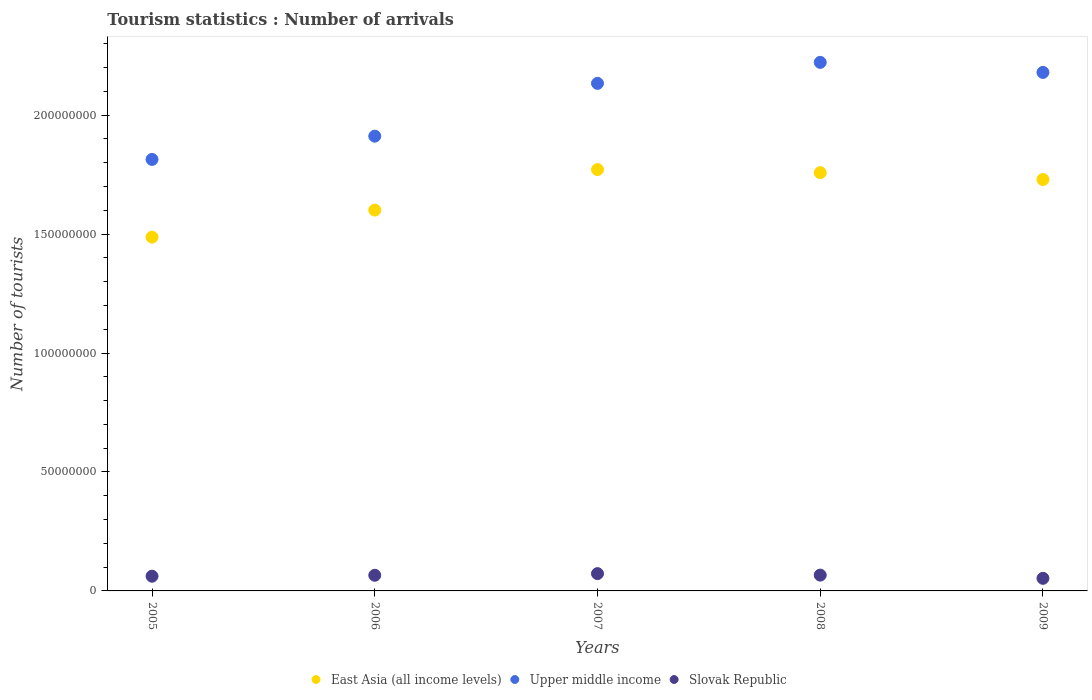How many different coloured dotlines are there?
Provide a short and direct response. 3. Is the number of dotlines equal to the number of legend labels?
Keep it short and to the point. Yes. What is the number of tourist arrivals in Slovak Republic in 2008?
Provide a short and direct response. 6.64e+06. Across all years, what is the maximum number of tourist arrivals in Slovak Republic?
Offer a very short reply. 7.27e+06. Across all years, what is the minimum number of tourist arrivals in Upper middle income?
Your answer should be compact. 1.81e+08. In which year was the number of tourist arrivals in East Asia (all income levels) maximum?
Provide a succinct answer. 2007. In which year was the number of tourist arrivals in East Asia (all income levels) minimum?
Offer a terse response. 2005. What is the total number of tourist arrivals in Slovak Republic in the graph?
Your answer should be very brief. 3.20e+07. What is the difference between the number of tourist arrivals in Slovak Republic in 2008 and that in 2009?
Keep it short and to the point. 1.34e+06. What is the difference between the number of tourist arrivals in Slovak Republic in 2006 and the number of tourist arrivals in Upper middle income in 2009?
Offer a terse response. -2.11e+08. What is the average number of tourist arrivals in East Asia (all income levels) per year?
Your answer should be compact. 1.67e+08. In the year 2007, what is the difference between the number of tourist arrivals in Upper middle income and number of tourist arrivals in East Asia (all income levels)?
Keep it short and to the point. 3.62e+07. In how many years, is the number of tourist arrivals in Upper middle income greater than 210000000?
Ensure brevity in your answer.  3. What is the ratio of the number of tourist arrivals in Upper middle income in 2005 to that in 2006?
Your answer should be very brief. 0.95. What is the difference between the highest and the second highest number of tourist arrivals in Upper middle income?
Give a very brief answer. 4.22e+06. What is the difference between the highest and the lowest number of tourist arrivals in East Asia (all income levels)?
Give a very brief answer. 2.84e+07. In how many years, is the number of tourist arrivals in East Asia (all income levels) greater than the average number of tourist arrivals in East Asia (all income levels) taken over all years?
Your response must be concise. 3. Is the sum of the number of tourist arrivals in East Asia (all income levels) in 2006 and 2008 greater than the maximum number of tourist arrivals in Upper middle income across all years?
Your answer should be compact. Yes. How many dotlines are there?
Provide a short and direct response. 3. What is the difference between two consecutive major ticks on the Y-axis?
Provide a short and direct response. 5.00e+07. Does the graph contain any zero values?
Make the answer very short. No. What is the title of the graph?
Make the answer very short. Tourism statistics : Number of arrivals. What is the label or title of the X-axis?
Provide a succinct answer. Years. What is the label or title of the Y-axis?
Provide a succinct answer. Number of tourists. What is the Number of tourists in East Asia (all income levels) in 2005?
Provide a succinct answer. 1.49e+08. What is the Number of tourists in Upper middle income in 2005?
Offer a terse response. 1.81e+08. What is the Number of tourists in Slovak Republic in 2005?
Make the answer very short. 6.18e+06. What is the Number of tourists of East Asia (all income levels) in 2006?
Provide a succinct answer. 1.60e+08. What is the Number of tourists of Upper middle income in 2006?
Make the answer very short. 1.91e+08. What is the Number of tourists in Slovak Republic in 2006?
Give a very brief answer. 6.58e+06. What is the Number of tourists of East Asia (all income levels) in 2007?
Your answer should be compact. 1.77e+08. What is the Number of tourists of Upper middle income in 2007?
Give a very brief answer. 2.13e+08. What is the Number of tourists of Slovak Republic in 2007?
Your response must be concise. 7.27e+06. What is the Number of tourists of East Asia (all income levels) in 2008?
Give a very brief answer. 1.76e+08. What is the Number of tourists of Upper middle income in 2008?
Keep it short and to the point. 2.22e+08. What is the Number of tourists of Slovak Republic in 2008?
Your answer should be very brief. 6.64e+06. What is the Number of tourists of East Asia (all income levels) in 2009?
Ensure brevity in your answer.  1.73e+08. What is the Number of tourists of Upper middle income in 2009?
Offer a terse response. 2.18e+08. What is the Number of tourists of Slovak Republic in 2009?
Offer a terse response. 5.30e+06. Across all years, what is the maximum Number of tourists of East Asia (all income levels)?
Your answer should be very brief. 1.77e+08. Across all years, what is the maximum Number of tourists of Upper middle income?
Provide a short and direct response. 2.22e+08. Across all years, what is the maximum Number of tourists of Slovak Republic?
Make the answer very short. 7.27e+06. Across all years, what is the minimum Number of tourists of East Asia (all income levels)?
Give a very brief answer. 1.49e+08. Across all years, what is the minimum Number of tourists in Upper middle income?
Your answer should be compact. 1.81e+08. Across all years, what is the minimum Number of tourists of Slovak Republic?
Keep it short and to the point. 5.30e+06. What is the total Number of tourists in East Asia (all income levels) in the graph?
Offer a terse response. 8.35e+08. What is the total Number of tourists of Upper middle income in the graph?
Provide a succinct answer. 1.03e+09. What is the total Number of tourists of Slovak Republic in the graph?
Keep it short and to the point. 3.20e+07. What is the difference between the Number of tourists of East Asia (all income levels) in 2005 and that in 2006?
Provide a short and direct response. -1.14e+07. What is the difference between the Number of tourists in Upper middle income in 2005 and that in 2006?
Give a very brief answer. -9.77e+06. What is the difference between the Number of tourists in Slovak Republic in 2005 and that in 2006?
Offer a terse response. -3.95e+05. What is the difference between the Number of tourists of East Asia (all income levels) in 2005 and that in 2007?
Keep it short and to the point. -2.84e+07. What is the difference between the Number of tourists of Upper middle income in 2005 and that in 2007?
Your answer should be compact. -3.20e+07. What is the difference between the Number of tourists of Slovak Republic in 2005 and that in 2007?
Your response must be concise. -1.08e+06. What is the difference between the Number of tourists in East Asia (all income levels) in 2005 and that in 2008?
Provide a succinct answer. -2.71e+07. What is the difference between the Number of tourists of Upper middle income in 2005 and that in 2008?
Provide a succinct answer. -4.08e+07. What is the difference between the Number of tourists of Slovak Republic in 2005 and that in 2008?
Offer a very short reply. -4.59e+05. What is the difference between the Number of tourists in East Asia (all income levels) in 2005 and that in 2009?
Provide a succinct answer. -2.42e+07. What is the difference between the Number of tourists of Upper middle income in 2005 and that in 2009?
Ensure brevity in your answer.  -3.66e+07. What is the difference between the Number of tourists in Slovak Republic in 2005 and that in 2009?
Provide a short and direct response. 8.86e+05. What is the difference between the Number of tourists of East Asia (all income levels) in 2006 and that in 2007?
Offer a very short reply. -1.70e+07. What is the difference between the Number of tourists in Upper middle income in 2006 and that in 2007?
Your answer should be compact. -2.22e+07. What is the difference between the Number of tourists in Slovak Republic in 2006 and that in 2007?
Offer a very short reply. -6.90e+05. What is the difference between the Number of tourists of East Asia (all income levels) in 2006 and that in 2008?
Keep it short and to the point. -1.57e+07. What is the difference between the Number of tourists in Upper middle income in 2006 and that in 2008?
Offer a very short reply. -3.10e+07. What is the difference between the Number of tourists of Slovak Republic in 2006 and that in 2008?
Provide a succinct answer. -6.40e+04. What is the difference between the Number of tourists in East Asia (all income levels) in 2006 and that in 2009?
Ensure brevity in your answer.  -1.29e+07. What is the difference between the Number of tourists of Upper middle income in 2006 and that in 2009?
Keep it short and to the point. -2.68e+07. What is the difference between the Number of tourists in Slovak Republic in 2006 and that in 2009?
Keep it short and to the point. 1.28e+06. What is the difference between the Number of tourists of East Asia (all income levels) in 2007 and that in 2008?
Give a very brief answer. 1.30e+06. What is the difference between the Number of tourists of Upper middle income in 2007 and that in 2008?
Provide a succinct answer. -8.82e+06. What is the difference between the Number of tourists in Slovak Republic in 2007 and that in 2008?
Provide a short and direct response. 6.26e+05. What is the difference between the Number of tourists of East Asia (all income levels) in 2007 and that in 2009?
Your answer should be compact. 4.18e+06. What is the difference between the Number of tourists in Upper middle income in 2007 and that in 2009?
Offer a very short reply. -4.60e+06. What is the difference between the Number of tourists in Slovak Republic in 2007 and that in 2009?
Keep it short and to the point. 1.97e+06. What is the difference between the Number of tourists of East Asia (all income levels) in 2008 and that in 2009?
Your answer should be very brief. 2.88e+06. What is the difference between the Number of tourists in Upper middle income in 2008 and that in 2009?
Your answer should be very brief. 4.22e+06. What is the difference between the Number of tourists of Slovak Republic in 2008 and that in 2009?
Offer a very short reply. 1.34e+06. What is the difference between the Number of tourists of East Asia (all income levels) in 2005 and the Number of tourists of Upper middle income in 2006?
Offer a terse response. -4.24e+07. What is the difference between the Number of tourists of East Asia (all income levels) in 2005 and the Number of tourists of Slovak Republic in 2006?
Provide a short and direct response. 1.42e+08. What is the difference between the Number of tourists in Upper middle income in 2005 and the Number of tourists in Slovak Republic in 2006?
Offer a terse response. 1.75e+08. What is the difference between the Number of tourists in East Asia (all income levels) in 2005 and the Number of tourists in Upper middle income in 2007?
Your response must be concise. -6.46e+07. What is the difference between the Number of tourists of East Asia (all income levels) in 2005 and the Number of tourists of Slovak Republic in 2007?
Keep it short and to the point. 1.41e+08. What is the difference between the Number of tourists in Upper middle income in 2005 and the Number of tourists in Slovak Republic in 2007?
Your answer should be compact. 1.74e+08. What is the difference between the Number of tourists of East Asia (all income levels) in 2005 and the Number of tourists of Upper middle income in 2008?
Your answer should be compact. -7.35e+07. What is the difference between the Number of tourists in East Asia (all income levels) in 2005 and the Number of tourists in Slovak Republic in 2008?
Your answer should be very brief. 1.42e+08. What is the difference between the Number of tourists in Upper middle income in 2005 and the Number of tourists in Slovak Republic in 2008?
Provide a succinct answer. 1.75e+08. What is the difference between the Number of tourists in East Asia (all income levels) in 2005 and the Number of tourists in Upper middle income in 2009?
Give a very brief answer. -6.92e+07. What is the difference between the Number of tourists of East Asia (all income levels) in 2005 and the Number of tourists of Slovak Republic in 2009?
Offer a terse response. 1.43e+08. What is the difference between the Number of tourists in Upper middle income in 2005 and the Number of tourists in Slovak Republic in 2009?
Your answer should be compact. 1.76e+08. What is the difference between the Number of tourists of East Asia (all income levels) in 2006 and the Number of tourists of Upper middle income in 2007?
Ensure brevity in your answer.  -5.33e+07. What is the difference between the Number of tourists in East Asia (all income levels) in 2006 and the Number of tourists in Slovak Republic in 2007?
Your answer should be very brief. 1.53e+08. What is the difference between the Number of tourists of Upper middle income in 2006 and the Number of tourists of Slovak Republic in 2007?
Keep it short and to the point. 1.84e+08. What is the difference between the Number of tourists in East Asia (all income levels) in 2006 and the Number of tourists in Upper middle income in 2008?
Give a very brief answer. -6.21e+07. What is the difference between the Number of tourists in East Asia (all income levels) in 2006 and the Number of tourists in Slovak Republic in 2008?
Ensure brevity in your answer.  1.53e+08. What is the difference between the Number of tourists of Upper middle income in 2006 and the Number of tourists of Slovak Republic in 2008?
Provide a short and direct response. 1.85e+08. What is the difference between the Number of tourists in East Asia (all income levels) in 2006 and the Number of tourists in Upper middle income in 2009?
Keep it short and to the point. -5.79e+07. What is the difference between the Number of tourists in East Asia (all income levels) in 2006 and the Number of tourists in Slovak Republic in 2009?
Provide a succinct answer. 1.55e+08. What is the difference between the Number of tourists in Upper middle income in 2006 and the Number of tourists in Slovak Republic in 2009?
Your answer should be compact. 1.86e+08. What is the difference between the Number of tourists of East Asia (all income levels) in 2007 and the Number of tourists of Upper middle income in 2008?
Make the answer very short. -4.51e+07. What is the difference between the Number of tourists of East Asia (all income levels) in 2007 and the Number of tourists of Slovak Republic in 2008?
Provide a succinct answer. 1.70e+08. What is the difference between the Number of tourists of Upper middle income in 2007 and the Number of tourists of Slovak Republic in 2008?
Your answer should be compact. 2.07e+08. What is the difference between the Number of tourists of East Asia (all income levels) in 2007 and the Number of tourists of Upper middle income in 2009?
Make the answer very short. -4.08e+07. What is the difference between the Number of tourists of East Asia (all income levels) in 2007 and the Number of tourists of Slovak Republic in 2009?
Provide a short and direct response. 1.72e+08. What is the difference between the Number of tourists in Upper middle income in 2007 and the Number of tourists in Slovak Republic in 2009?
Your answer should be very brief. 2.08e+08. What is the difference between the Number of tourists of East Asia (all income levels) in 2008 and the Number of tourists of Upper middle income in 2009?
Your response must be concise. -4.21e+07. What is the difference between the Number of tourists of East Asia (all income levels) in 2008 and the Number of tourists of Slovak Republic in 2009?
Make the answer very short. 1.71e+08. What is the difference between the Number of tourists in Upper middle income in 2008 and the Number of tourists in Slovak Republic in 2009?
Your answer should be compact. 2.17e+08. What is the average Number of tourists in East Asia (all income levels) per year?
Keep it short and to the point. 1.67e+08. What is the average Number of tourists in Upper middle income per year?
Your answer should be compact. 2.05e+08. What is the average Number of tourists in Slovak Republic per year?
Your answer should be very brief. 6.39e+06. In the year 2005, what is the difference between the Number of tourists of East Asia (all income levels) and Number of tourists of Upper middle income?
Provide a short and direct response. -3.27e+07. In the year 2005, what is the difference between the Number of tourists of East Asia (all income levels) and Number of tourists of Slovak Republic?
Your answer should be very brief. 1.43e+08. In the year 2005, what is the difference between the Number of tourists of Upper middle income and Number of tourists of Slovak Republic?
Ensure brevity in your answer.  1.75e+08. In the year 2006, what is the difference between the Number of tourists in East Asia (all income levels) and Number of tourists in Upper middle income?
Make the answer very short. -3.11e+07. In the year 2006, what is the difference between the Number of tourists in East Asia (all income levels) and Number of tourists in Slovak Republic?
Provide a succinct answer. 1.53e+08. In the year 2006, what is the difference between the Number of tourists of Upper middle income and Number of tourists of Slovak Republic?
Provide a succinct answer. 1.85e+08. In the year 2007, what is the difference between the Number of tourists of East Asia (all income levels) and Number of tourists of Upper middle income?
Offer a terse response. -3.62e+07. In the year 2007, what is the difference between the Number of tourists of East Asia (all income levels) and Number of tourists of Slovak Republic?
Provide a short and direct response. 1.70e+08. In the year 2007, what is the difference between the Number of tourists in Upper middle income and Number of tourists in Slovak Republic?
Provide a short and direct response. 2.06e+08. In the year 2008, what is the difference between the Number of tourists of East Asia (all income levels) and Number of tourists of Upper middle income?
Make the answer very short. -4.64e+07. In the year 2008, what is the difference between the Number of tourists of East Asia (all income levels) and Number of tourists of Slovak Republic?
Give a very brief answer. 1.69e+08. In the year 2008, what is the difference between the Number of tourists of Upper middle income and Number of tourists of Slovak Republic?
Your answer should be very brief. 2.16e+08. In the year 2009, what is the difference between the Number of tourists in East Asia (all income levels) and Number of tourists in Upper middle income?
Provide a short and direct response. -4.50e+07. In the year 2009, what is the difference between the Number of tourists of East Asia (all income levels) and Number of tourists of Slovak Republic?
Offer a terse response. 1.68e+08. In the year 2009, what is the difference between the Number of tourists of Upper middle income and Number of tourists of Slovak Republic?
Your answer should be very brief. 2.13e+08. What is the ratio of the Number of tourists in East Asia (all income levels) in 2005 to that in 2006?
Give a very brief answer. 0.93. What is the ratio of the Number of tourists in Upper middle income in 2005 to that in 2006?
Keep it short and to the point. 0.95. What is the ratio of the Number of tourists in East Asia (all income levels) in 2005 to that in 2007?
Your answer should be compact. 0.84. What is the ratio of the Number of tourists in Upper middle income in 2005 to that in 2007?
Provide a short and direct response. 0.85. What is the ratio of the Number of tourists of Slovak Republic in 2005 to that in 2007?
Ensure brevity in your answer.  0.85. What is the ratio of the Number of tourists of East Asia (all income levels) in 2005 to that in 2008?
Your answer should be compact. 0.85. What is the ratio of the Number of tourists of Upper middle income in 2005 to that in 2008?
Keep it short and to the point. 0.82. What is the ratio of the Number of tourists in Slovak Republic in 2005 to that in 2008?
Give a very brief answer. 0.93. What is the ratio of the Number of tourists in East Asia (all income levels) in 2005 to that in 2009?
Offer a very short reply. 0.86. What is the ratio of the Number of tourists in Upper middle income in 2005 to that in 2009?
Ensure brevity in your answer.  0.83. What is the ratio of the Number of tourists in Slovak Republic in 2005 to that in 2009?
Your answer should be compact. 1.17. What is the ratio of the Number of tourists in East Asia (all income levels) in 2006 to that in 2007?
Provide a succinct answer. 0.9. What is the ratio of the Number of tourists of Upper middle income in 2006 to that in 2007?
Your answer should be very brief. 0.9. What is the ratio of the Number of tourists of Slovak Republic in 2006 to that in 2007?
Offer a terse response. 0.91. What is the ratio of the Number of tourists in East Asia (all income levels) in 2006 to that in 2008?
Provide a succinct answer. 0.91. What is the ratio of the Number of tourists of Upper middle income in 2006 to that in 2008?
Ensure brevity in your answer.  0.86. What is the ratio of the Number of tourists of Slovak Republic in 2006 to that in 2008?
Ensure brevity in your answer.  0.99. What is the ratio of the Number of tourists in East Asia (all income levels) in 2006 to that in 2009?
Offer a very short reply. 0.93. What is the ratio of the Number of tourists in Upper middle income in 2006 to that in 2009?
Keep it short and to the point. 0.88. What is the ratio of the Number of tourists of Slovak Republic in 2006 to that in 2009?
Ensure brevity in your answer.  1.24. What is the ratio of the Number of tourists of East Asia (all income levels) in 2007 to that in 2008?
Ensure brevity in your answer.  1.01. What is the ratio of the Number of tourists in Upper middle income in 2007 to that in 2008?
Your response must be concise. 0.96. What is the ratio of the Number of tourists of Slovak Republic in 2007 to that in 2008?
Give a very brief answer. 1.09. What is the ratio of the Number of tourists in East Asia (all income levels) in 2007 to that in 2009?
Make the answer very short. 1.02. What is the ratio of the Number of tourists of Upper middle income in 2007 to that in 2009?
Ensure brevity in your answer.  0.98. What is the ratio of the Number of tourists of Slovak Republic in 2007 to that in 2009?
Your response must be concise. 1.37. What is the ratio of the Number of tourists in East Asia (all income levels) in 2008 to that in 2009?
Keep it short and to the point. 1.02. What is the ratio of the Number of tourists of Upper middle income in 2008 to that in 2009?
Offer a terse response. 1.02. What is the ratio of the Number of tourists of Slovak Republic in 2008 to that in 2009?
Offer a very short reply. 1.25. What is the difference between the highest and the second highest Number of tourists in East Asia (all income levels)?
Provide a succinct answer. 1.30e+06. What is the difference between the highest and the second highest Number of tourists of Upper middle income?
Your answer should be very brief. 4.22e+06. What is the difference between the highest and the second highest Number of tourists of Slovak Republic?
Offer a very short reply. 6.26e+05. What is the difference between the highest and the lowest Number of tourists of East Asia (all income levels)?
Your answer should be very brief. 2.84e+07. What is the difference between the highest and the lowest Number of tourists in Upper middle income?
Provide a short and direct response. 4.08e+07. What is the difference between the highest and the lowest Number of tourists in Slovak Republic?
Keep it short and to the point. 1.97e+06. 